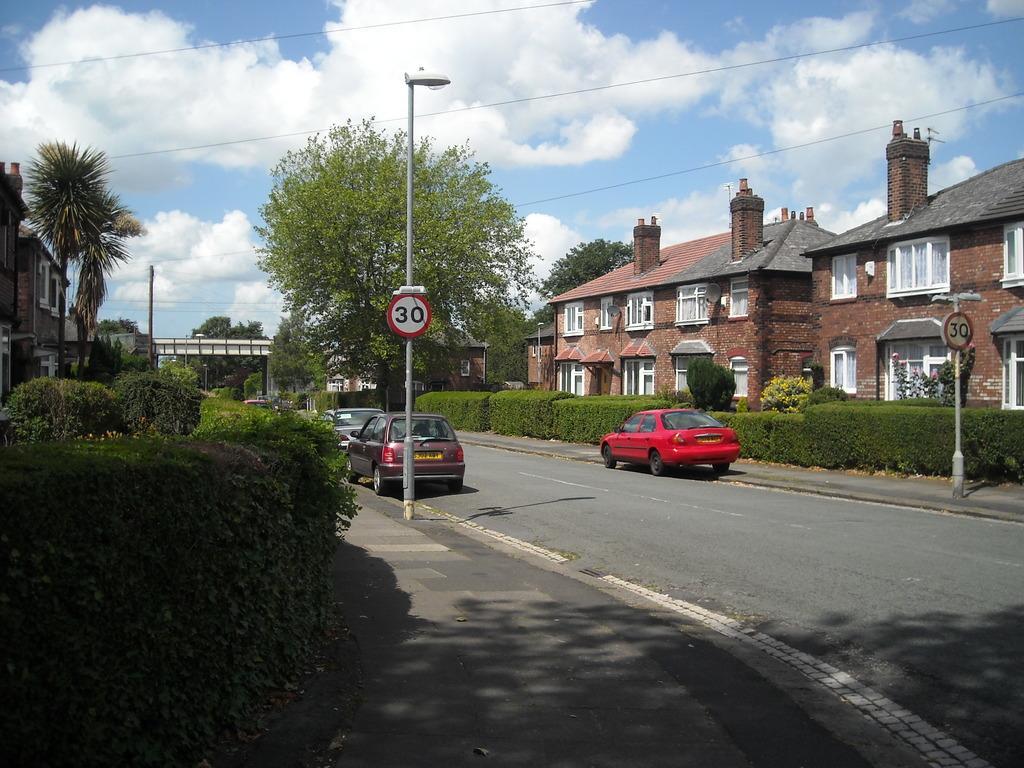How would you summarize this image in a sentence or two? In this image we can see buildings, trees, plants, poles with lights and boards, there are wires and the sky with clouds in the background. 